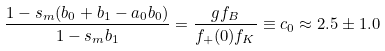<formula> <loc_0><loc_0><loc_500><loc_500>\frac { 1 - s _ { m } ( b _ { 0 } + b _ { 1 } - a _ { 0 } b _ { 0 } ) } { 1 - s _ { m } b _ { 1 } } = \frac { g f _ { B } } { f _ { + } ( 0 ) f _ { K } } \equiv c _ { 0 } \approx 2 . 5 \pm 1 . 0</formula> 